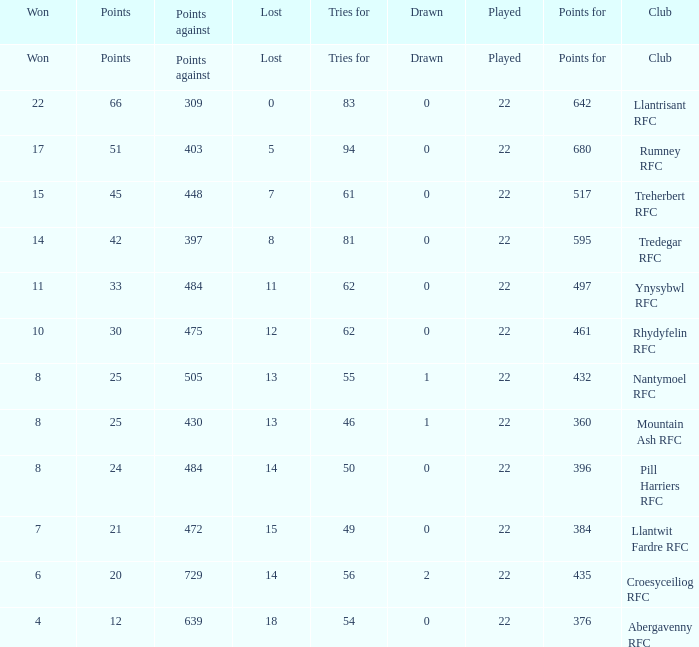Which club lost exactly 7 matches? Treherbert RFC. 